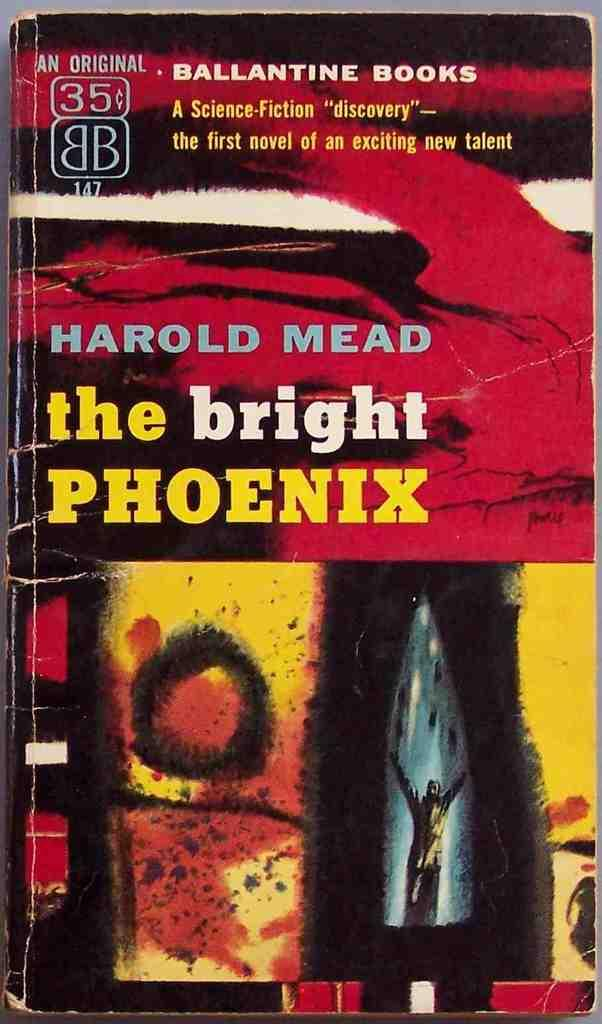<image>
Provide a brief description of the given image. a book by HAROLD MEAD entitled the bright PHOENIX from BALLANTINE BOOKS. 